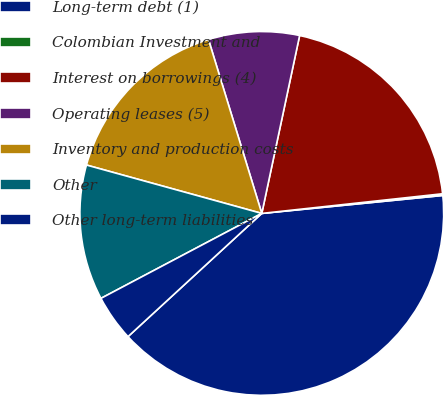Convert chart. <chart><loc_0><loc_0><loc_500><loc_500><pie_chart><fcel>Long-term debt (1)<fcel>Colombian Investment and<fcel>Interest on borrowings (4)<fcel>Operating leases (5)<fcel>Inventory and production costs<fcel>Other<fcel>Other long-term liabilities<nl><fcel>39.73%<fcel>0.15%<fcel>19.94%<fcel>8.07%<fcel>15.98%<fcel>12.02%<fcel>4.11%<nl></chart> 